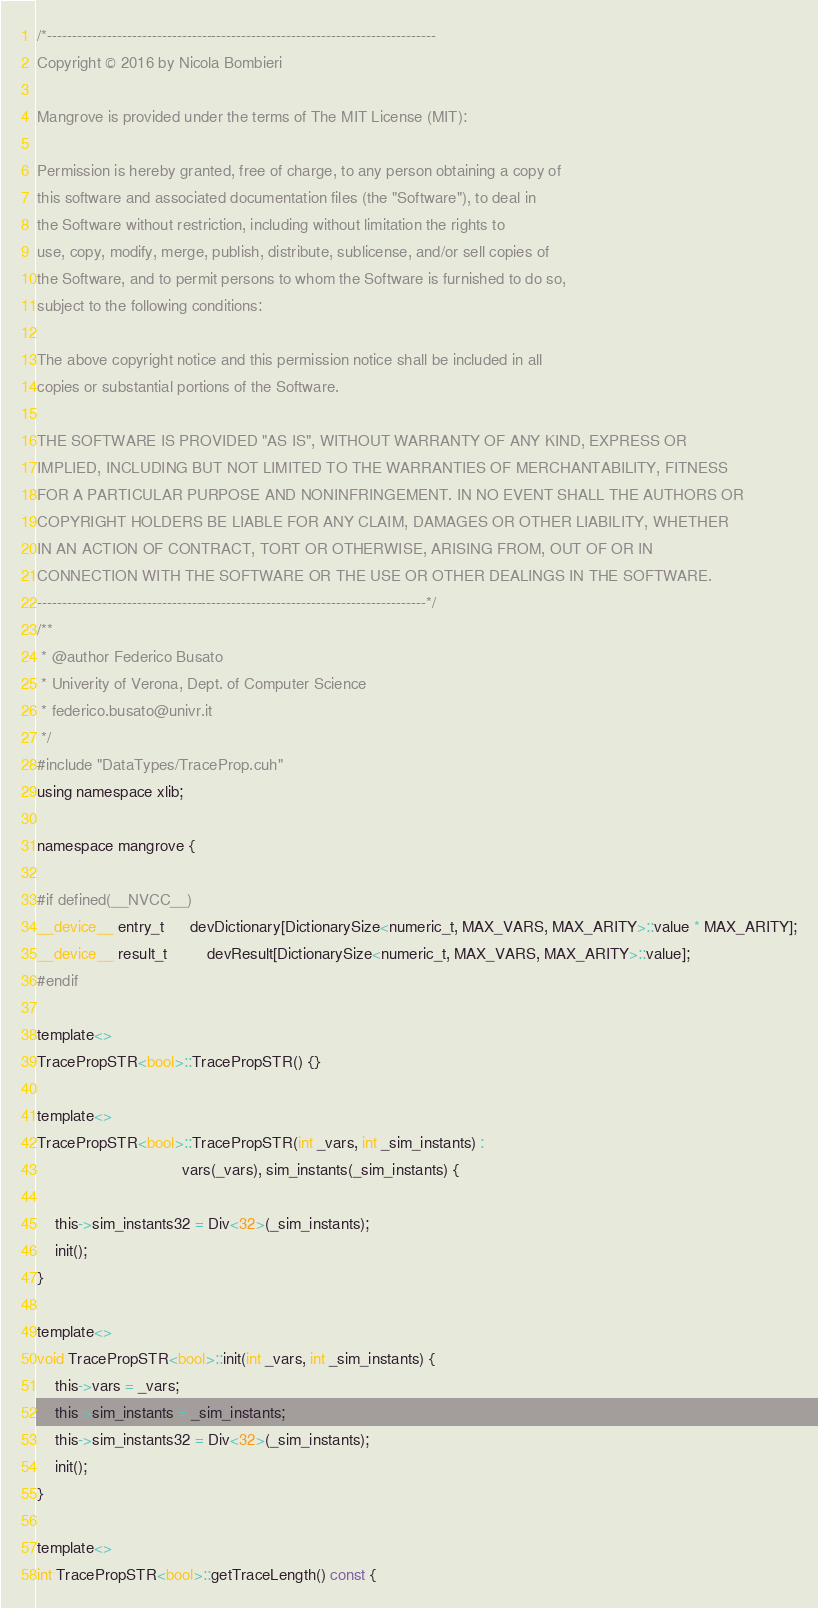Convert code to text. <code><loc_0><loc_0><loc_500><loc_500><_Cuda_>/*------------------------------------------------------------------------------
Copyright © 2016 by Nicola Bombieri

Mangrove is provided under the terms of The MIT License (MIT):

Permission is hereby granted, free of charge, to any person obtaining a copy of
this software and associated documentation files (the "Software"), to deal in
the Software without restriction, including without limitation the rights to
use, copy, modify, merge, publish, distribute, sublicense, and/or sell copies of
the Software, and to permit persons to whom the Software is furnished to do so,
subject to the following conditions:

The above copyright notice and this permission notice shall be included in all
copies or substantial portions of the Software.

THE SOFTWARE IS PROVIDED "AS IS", WITHOUT WARRANTY OF ANY KIND, EXPRESS OR
IMPLIED, INCLUDING BUT NOT LIMITED TO THE WARRANTIES OF MERCHANTABILITY, FITNESS
FOR A PARTICULAR PURPOSE AND NONINFRINGEMENT. IN NO EVENT SHALL THE AUTHORS OR
COPYRIGHT HOLDERS BE LIABLE FOR ANY CLAIM, DAMAGES OR OTHER LIABILITY, WHETHER
IN AN ACTION OF CONTRACT, TORT OR OTHERWISE, ARISING FROM, OUT OF OR IN
CONNECTION WITH THE SOFTWARE OR THE USE OR OTHER DEALINGS IN THE SOFTWARE.
------------------------------------------------------------------------------*/
/**
 * @author Federico Busato
 * Univerity of Verona, Dept. of Computer Science
 * federico.busato@univr.it
 */
#include "DataTypes/TraceProp.cuh"
using namespace xlib;

namespace mangrove {

#if defined(__NVCC__)
__device__ entry_t      devDictionary[DictionarySize<numeric_t, MAX_VARS, MAX_ARITY>::value * MAX_ARITY];
__device__ result_t         devResult[DictionarySize<numeric_t, MAX_VARS, MAX_ARITY>::value];
#endif

template<>
TracePropSTR<bool>::TracePropSTR() {}

template<>
TracePropSTR<bool>::TracePropSTR(int _vars, int _sim_instants) :
                                 vars(_vars), sim_instants(_sim_instants) {

    this->sim_instants32 = Div<32>(_sim_instants);
    init();
}

template<>
void TracePropSTR<bool>::init(int _vars, int _sim_instants) {
    this->vars = _vars;
    this->sim_instants = _sim_instants;
    this->sim_instants32 = Div<32>(_sim_instants);
    init();
}

template<>
int TracePropSTR<bool>::getTraceLength() const {</code> 